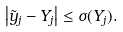Convert formula to latex. <formula><loc_0><loc_0><loc_500><loc_500>\left | \tilde { y } _ { j } - Y _ { j } \right | \leq \sigma ( Y _ { j } ) .</formula> 